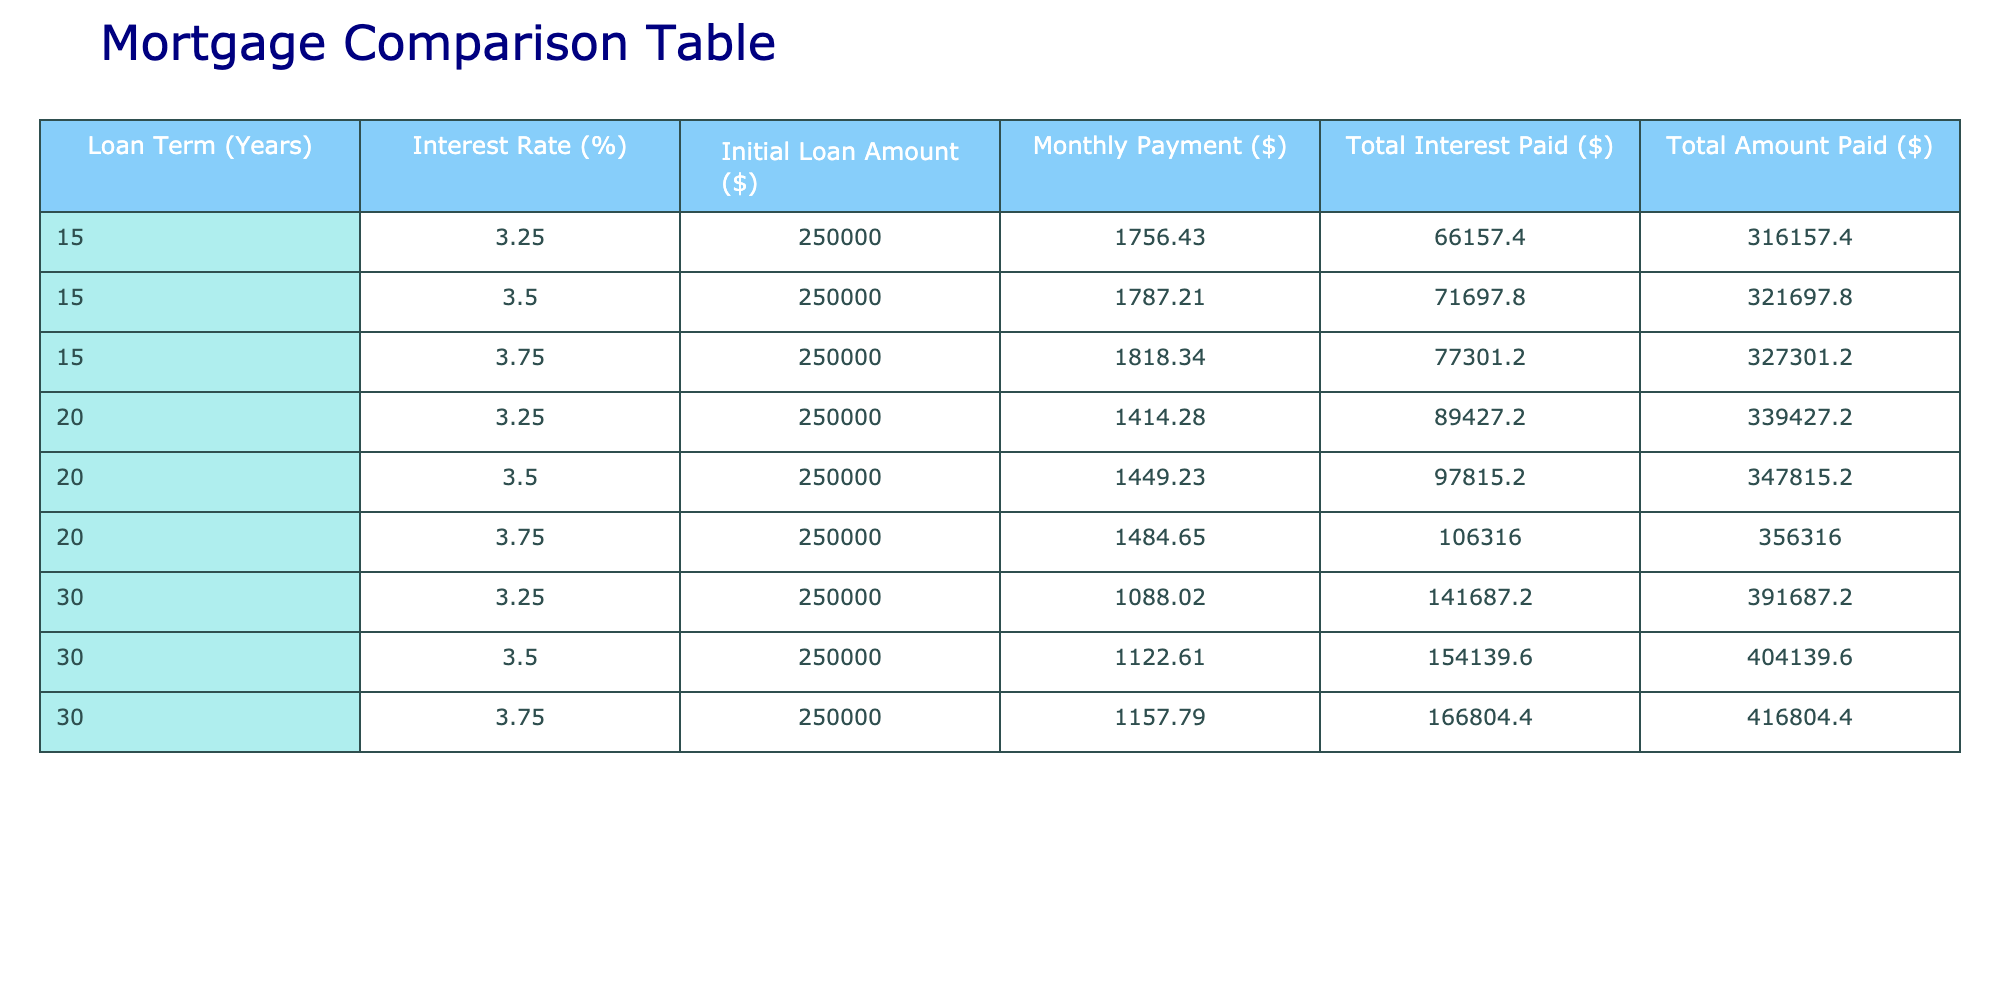What is the monthly payment for a 30-year loan at an interest rate of 3.50%? The table shows a monthly payment of $1,122.61 for a 30-year loan at an interest rate of 3.50%.
Answer: $1,122.61 What is the total interest paid on a 15-year loan with a 3.75% interest rate? The table indicates that for a 15-year loan with a 3.75% interest rate, the total interest paid is $77,301.20.
Answer: $77,301.20 What loan term results in the highest total amount paid? By comparing the total amounts paid across all the loan terms, the 30-year loan at 3.75% has the highest total amount paid at $416,804.40.
Answer: 30 years at 3.75% What is the difference in total interest paid between a 20-year loan at 3.25% and a 20-year loan at 3.75%? The total interest paid for a 20-year loan at 3.25% is $89,427.20 and for 3.75% is $106,316.00. The difference is $106,316.00 - $89,427.20 = $16,888.80.
Answer: $16,888.80 Is the monthly payment for the 15-year loan at 3.50% higher than the monthly payment for the 20-year loan at 3.25%? The monthly payment for the 15-year loan at 3.50% is $1,787.21, while the payment for the 20-year loan at 3.25% is $1,414.28. Since $1,787.21 is greater than $1,414.28, the statement is true.
Answer: Yes What is the average total interest paid across all loan terms and interest rates listed in the table? To find the average total interest paid, sum all total interest values: ($66,157.40 + $71,697.80 + $77,301.20 + $89,427.20 + $97,815.20 + $106,316.00 + $141,687.20 + $154,139.60 + $166,804.40) = $593,591.60. There are 9 data points, so the average is $593,591.60 / 9 = $65,399.07.
Answer: $65,399.07 What loan term offers the lowest monthly payment among the options presented? By comparing the monthly payments listed, the lowest monthly payment is $1,088.02 for the 30-year loan at an interest rate of 3.25%.
Answer: 30 years at 3.25% If I choose a 15-year loan at 3.25%, how much total amount would I pay including principal and interest? For a 15-year loan at 3.25%, the table shows that the total amount paid is $316,157.40, which includes both the principal and interest payments.
Answer: $316,157.40 